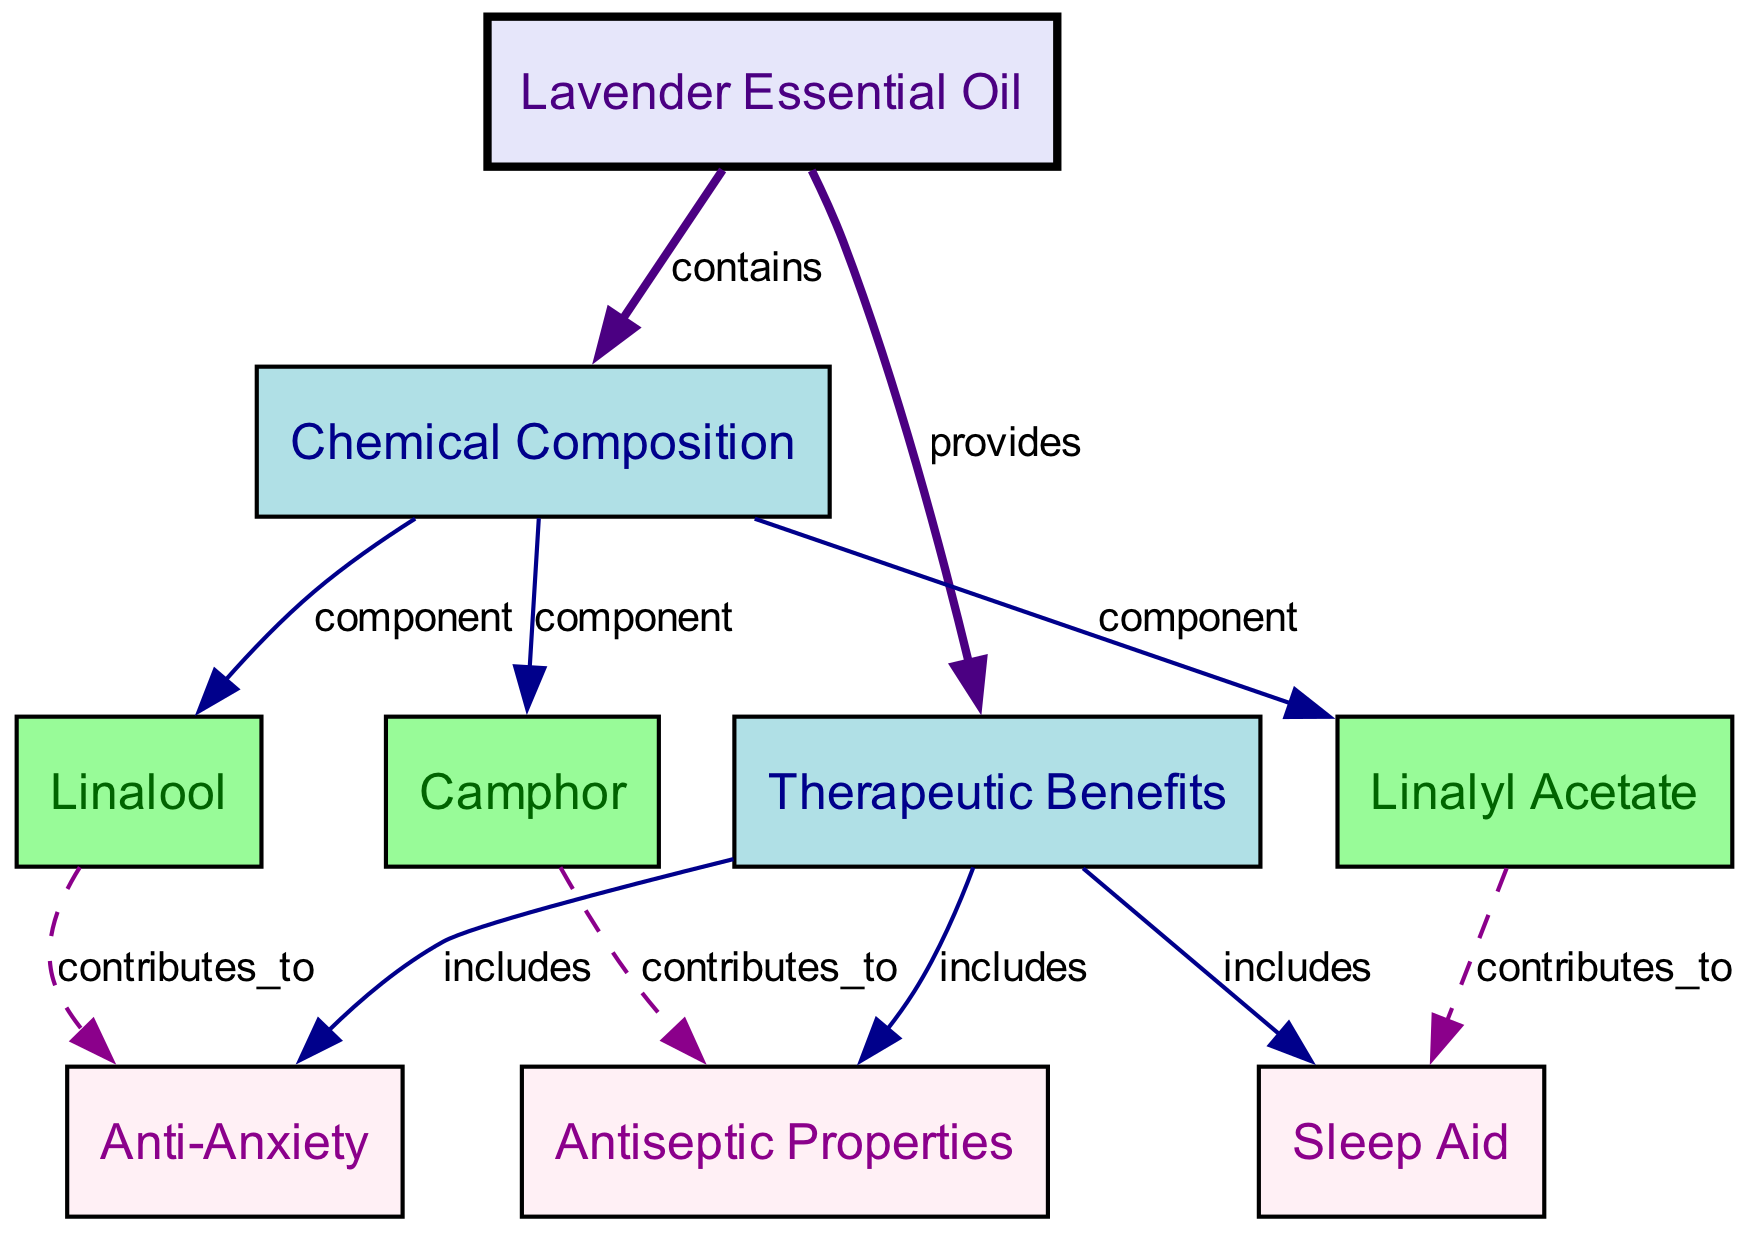What are the main components of lavender essential oil? The diagram lists three components of lavender essential oil under the "Chemical Composition" node: linalool, linalyl acetate, and camphor.
Answer: linalool, linalyl acetate, camphor How many therapeutic benefits are included in the diagram? The "Therapeutic Benefits" node connects to three benefits: anti-anxiety, sleep aid, and antiseptic properties. Thus, the total number of benefits is three.
Answer: 3 What contribution does linalool make to lavender's therapeutic effects? The diagram shows that linalool contributes to the anti-anxiety benefit of lavender essential oil, indicating its specific therapeutic role.
Answer: anti-anxiety Which component contributes to the antiseptic properties of lavender essential oil? According to the diagram, camphor is connected to the antiseptic properties, indicating its contribution within the context of lavender essential oil's benefits.
Answer: camphor What is the relationship between lavender essential oil and its chemical composition? The diagram states that lavender essential oil "contains" chemical components, establishing a direct link between the essential oil and its composition.
Answer: contains 